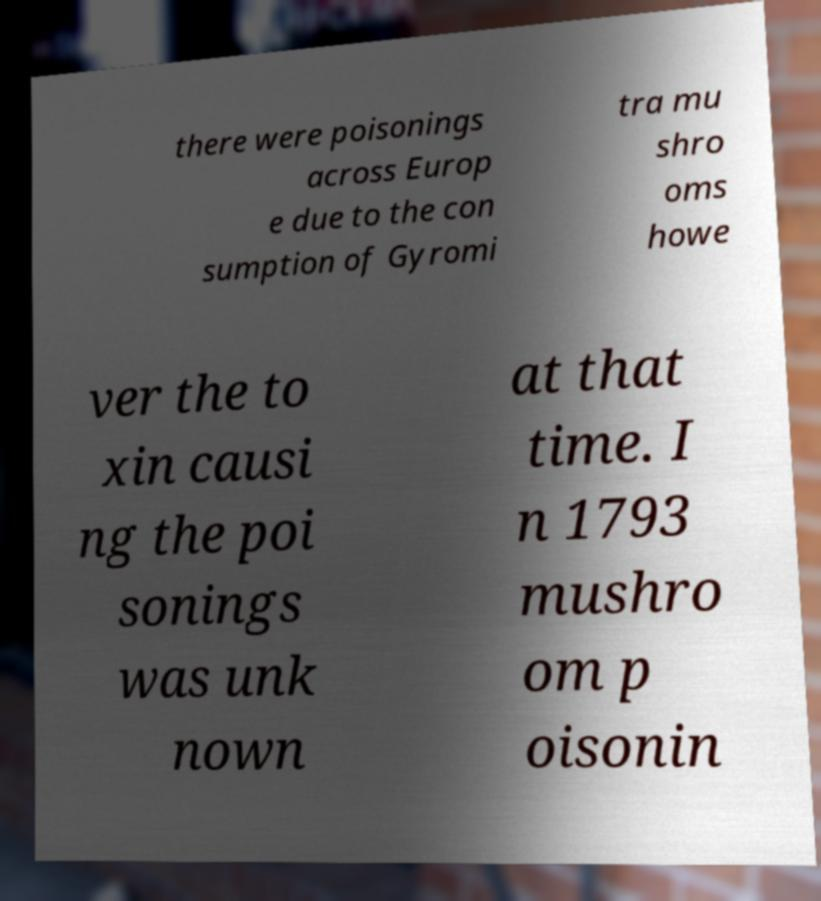Can you accurately transcribe the text from the provided image for me? there were poisonings across Europ e due to the con sumption of Gyromi tra mu shro oms howe ver the to xin causi ng the poi sonings was unk nown at that time. I n 1793 mushro om p oisonin 